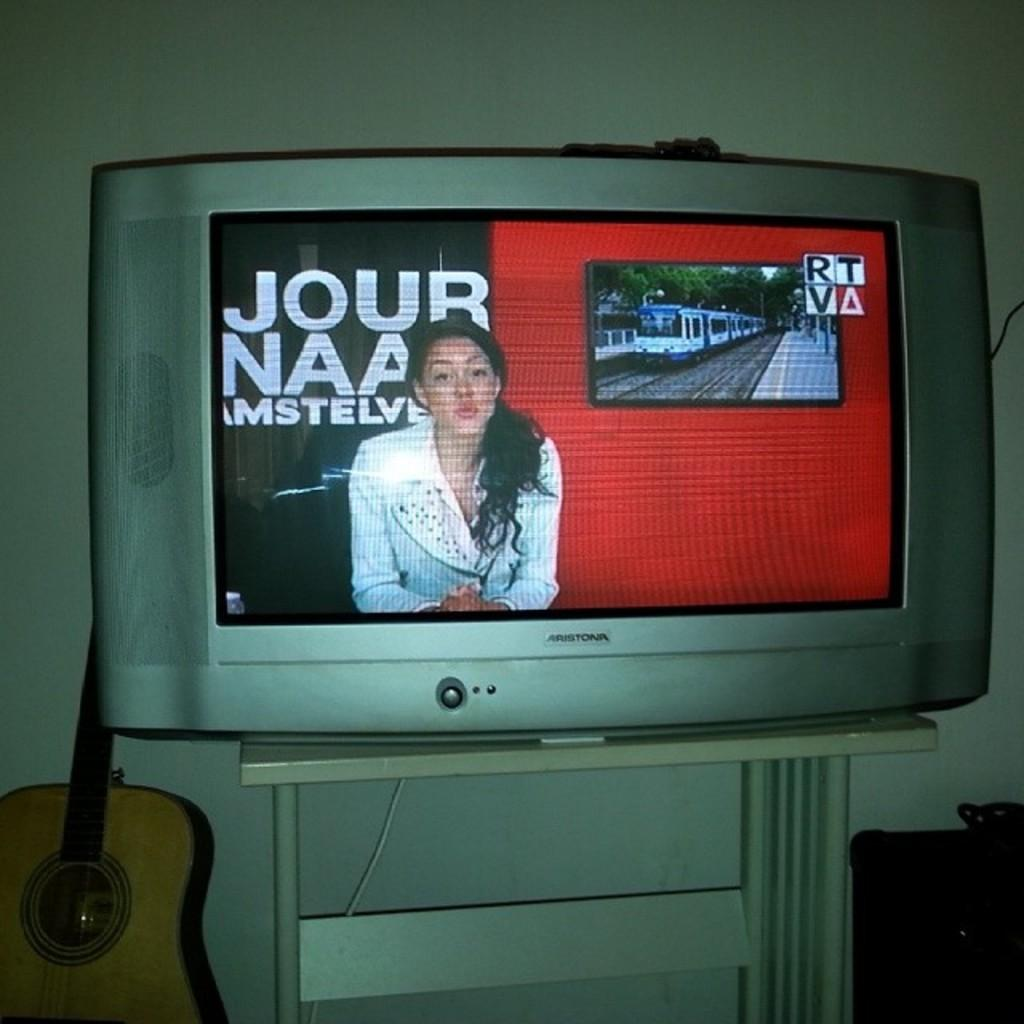<image>
Summarize the visual content of the image. A female newscaster on RTV is doing a newscast. 